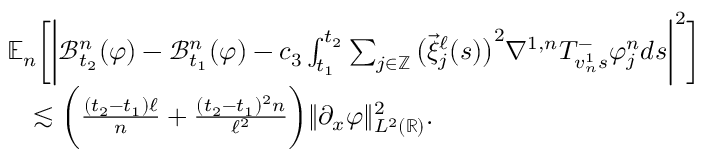<formula> <loc_0><loc_0><loc_500><loc_500>\begin{array} { r l } & { \mathbb { E } _ { n } \left [ \left | \mathcal { B } _ { t _ { 2 } } ^ { n } ( \varphi ) - \mathcal { B } _ { t _ { 1 } } ^ { n } ( \varphi ) - c _ { 3 } \int _ { t _ { 1 } } ^ { t _ { 2 } } \sum _ { j \in \mathbb { Z } } \left ( \overrightarrow { \xi } _ { j } ^ { \ell } ( s ) \right ) ^ { 2 } \nabla ^ { 1 , n } T _ { v _ { n } ^ { 1 } s } ^ { - } \varphi _ { j } ^ { n } d s \right | ^ { 2 } \right ] } \\ & { \quad \lesssim \left ( \frac { ( t _ { 2 } - t _ { 1 } ) \ell } { n } + \frac { ( t _ { 2 } - t _ { 1 } ) ^ { 2 } n } { \ell ^ { 2 } } \right ) \| \partial _ { x } \varphi \| _ { L ^ { 2 } ( \mathbb { R } ) } ^ { 2 } . } \end{array}</formula> 